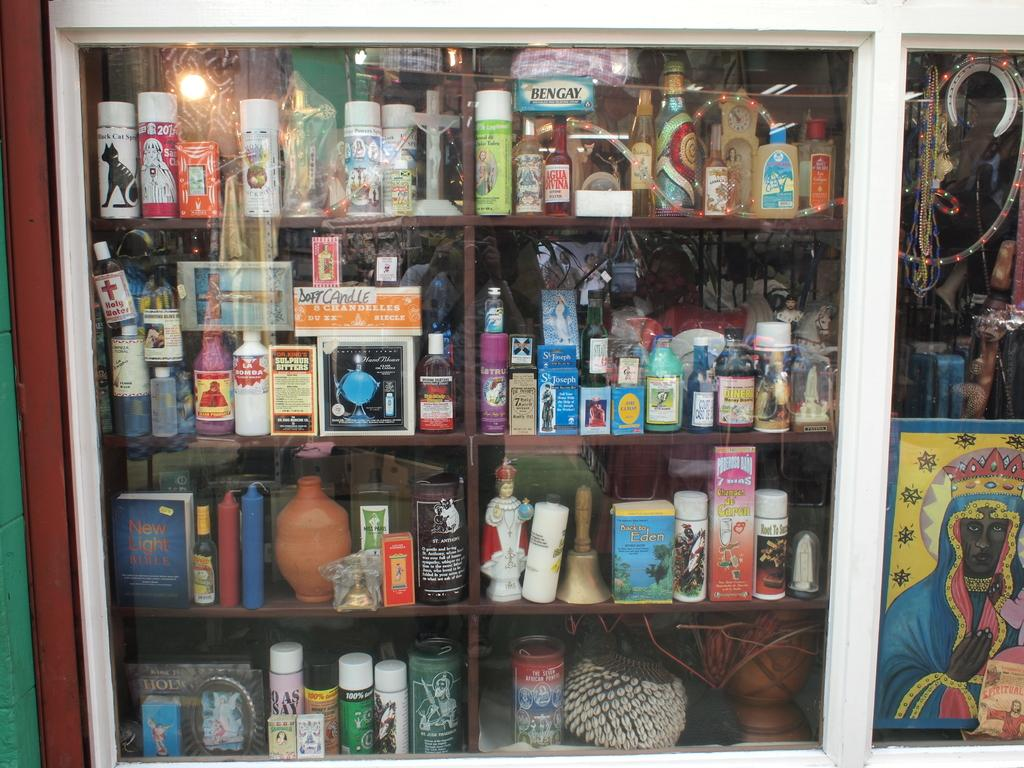Provide a one-sentence caption for the provided image. shelves behind a glass with an item labeled 'la bomba'. 